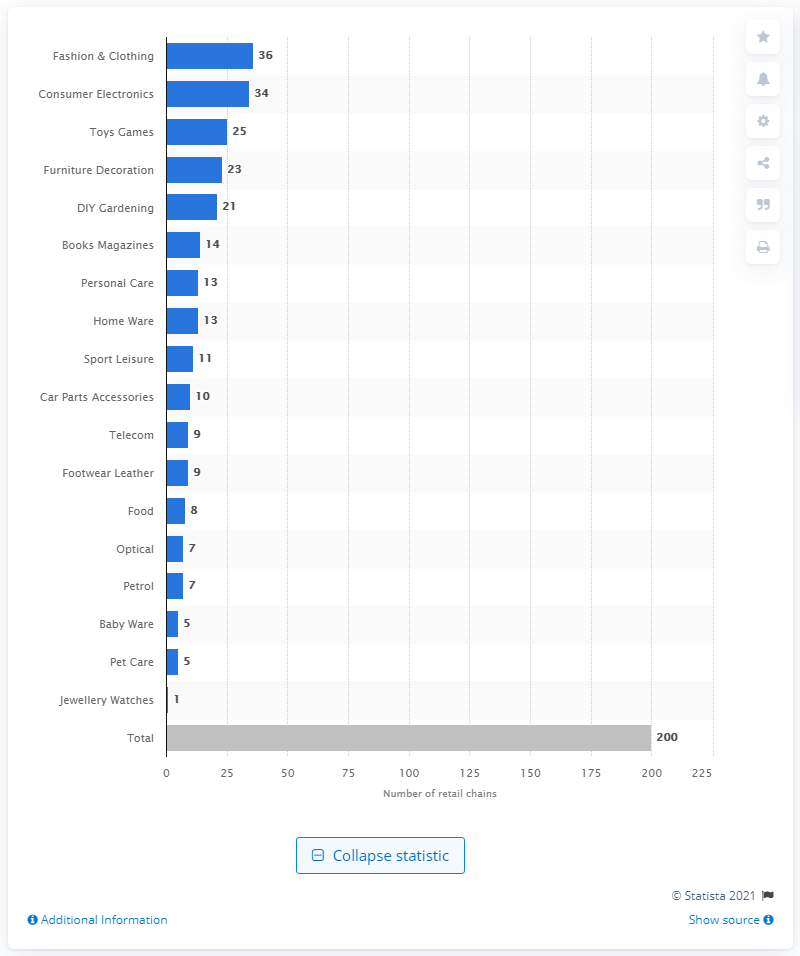Point out several critical features in this image. In 2016, there were 36 retail chains in the fashion and clothing industry in Sweden. In 2016, consumer electronics were represented by 34 retail chains in Sweden. 